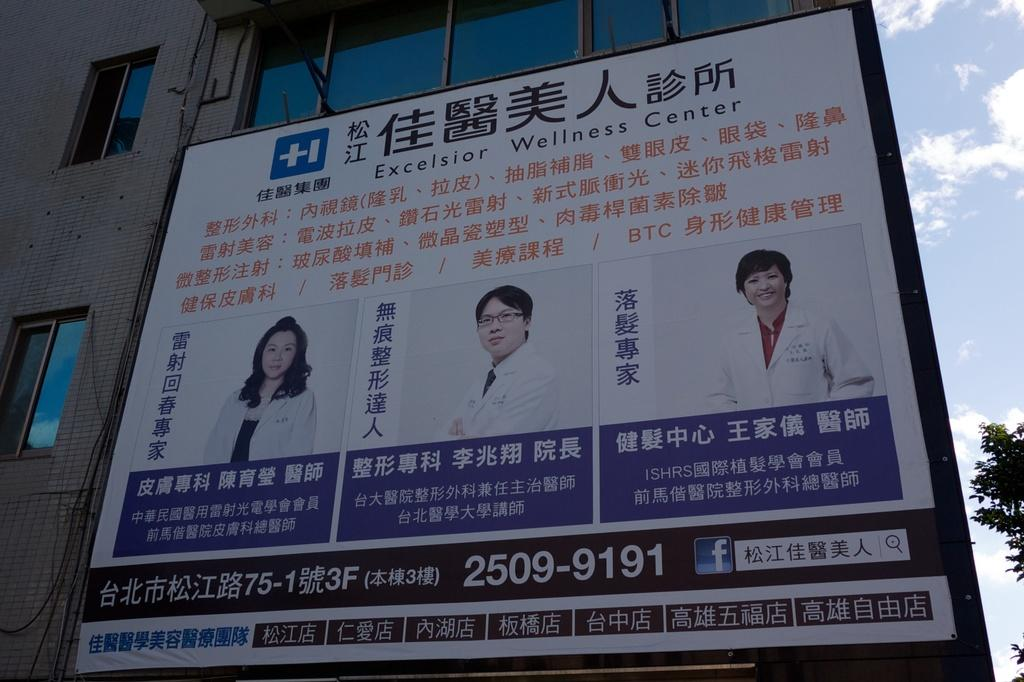<image>
Give a short and clear explanation of the subsequent image. Ad on a building for "Excelsior Wellness Center". 